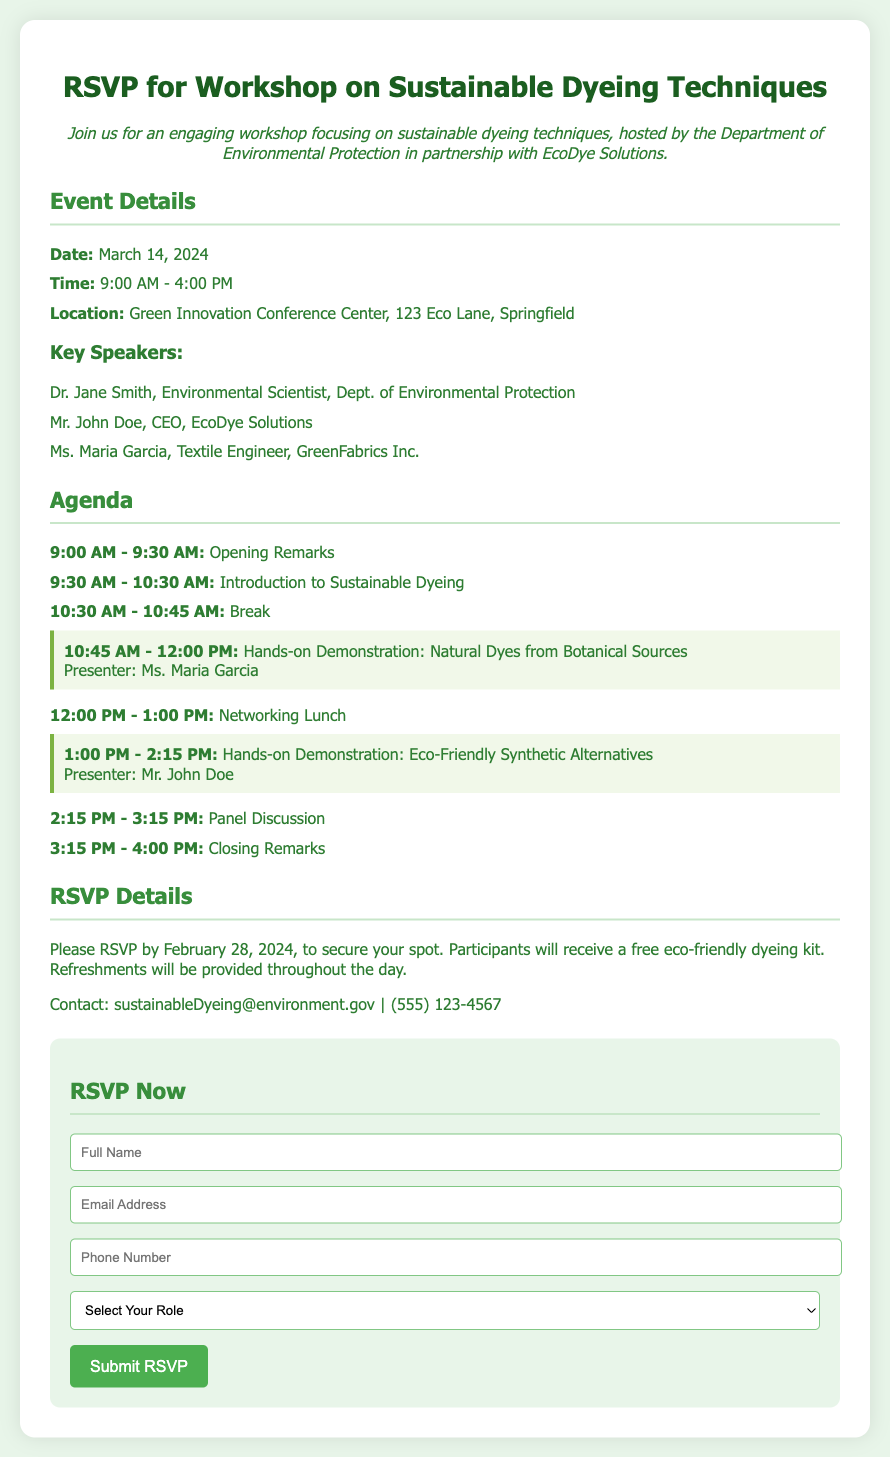what is the date of the workshop? The date of the workshop is explicitly stated in the event details section of the document.
Answer: March 14, 2024 what is the location of the event? The location is given in the event details section, providing the venue name and address.
Answer: Green Innovation Conference Center, 123 Eco Lane, Springfield who will present the demonstration on natural dyes? The presenter's name for the natural dyes demonstration is mentioned in the agenda section.
Answer: Ms. Maria Garcia what is the registration deadline for the workshop? The deadline for RSVPing is clearly noted in the RSVP details part of the document.
Answer: February 28, 2024 how many hands-on demonstrations are scheduled? The number of hands-on demonstrations can be inferred from the agenda section where they are listed.
Answer: 2 what contact email is provided for more information? The RSVP details section contains a contact email for inquiries regarding the workshop.
Answer: sustainableDyeing@environment.gov which organization is partnering to host the workshop? The hosting organization mentioned in the introduction specifies the collaborative effort for the event.
Answer: EcoDye Solutions what type of kit will participants receive? The information about the kit is highlighted in the RSVP details section regarding participant benefits.
Answer: eco-friendly dyeing kit 